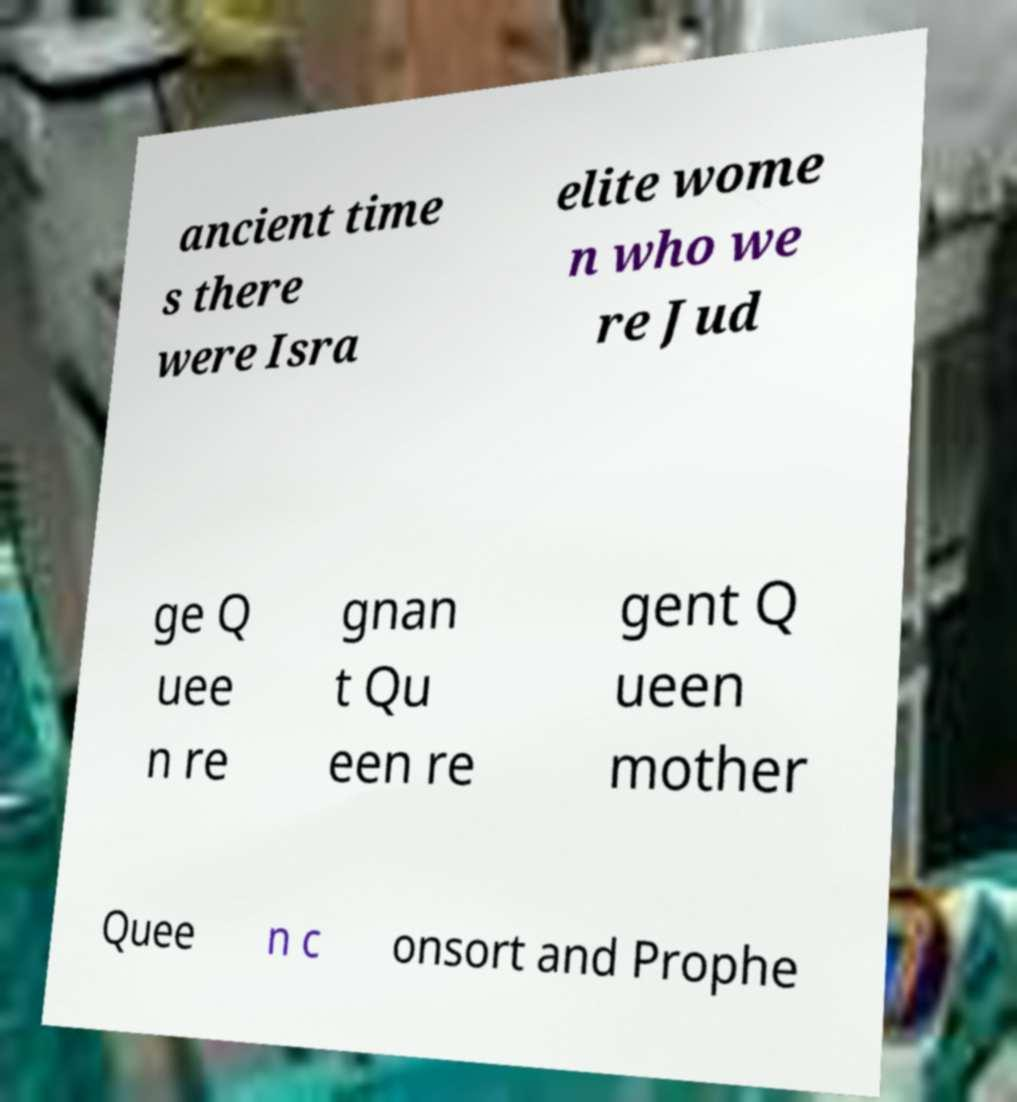I need the written content from this picture converted into text. Can you do that? ancient time s there were Isra elite wome n who we re Jud ge Q uee n re gnan t Qu een re gent Q ueen mother Quee n c onsort and Prophe 